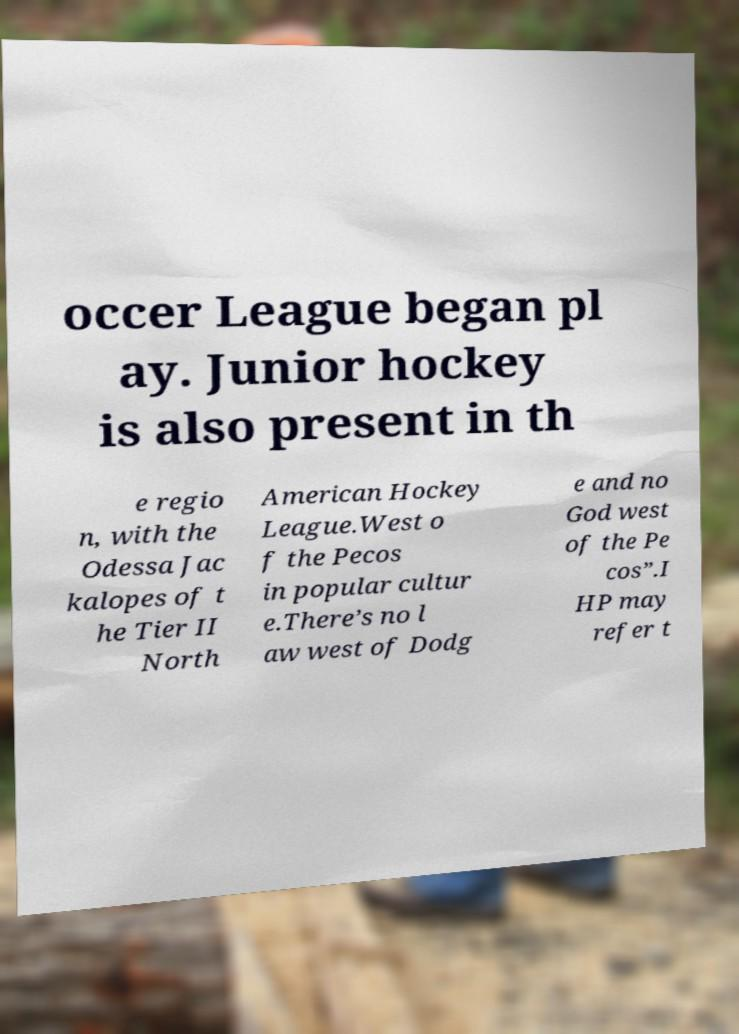For documentation purposes, I need the text within this image transcribed. Could you provide that? occer League began pl ay. Junior hockey is also present in th e regio n, with the Odessa Jac kalopes of t he Tier II North American Hockey League.West o f the Pecos in popular cultur e.There’s no l aw west of Dodg e and no God west of the Pe cos”.I HP may refer t 